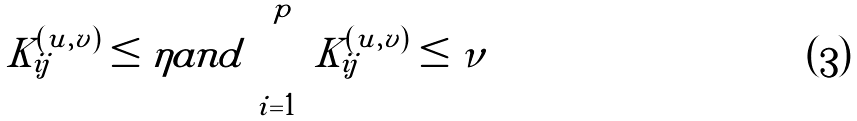Convert formula to latex. <formula><loc_0><loc_0><loc_500><loc_500>{ } K _ { i j } ^ { ( u , v ) } \leq \eta a n d \sum _ { i = 1 } ^ { p } K _ { i j } ^ { ( u , v ) } \leq \nu</formula> 